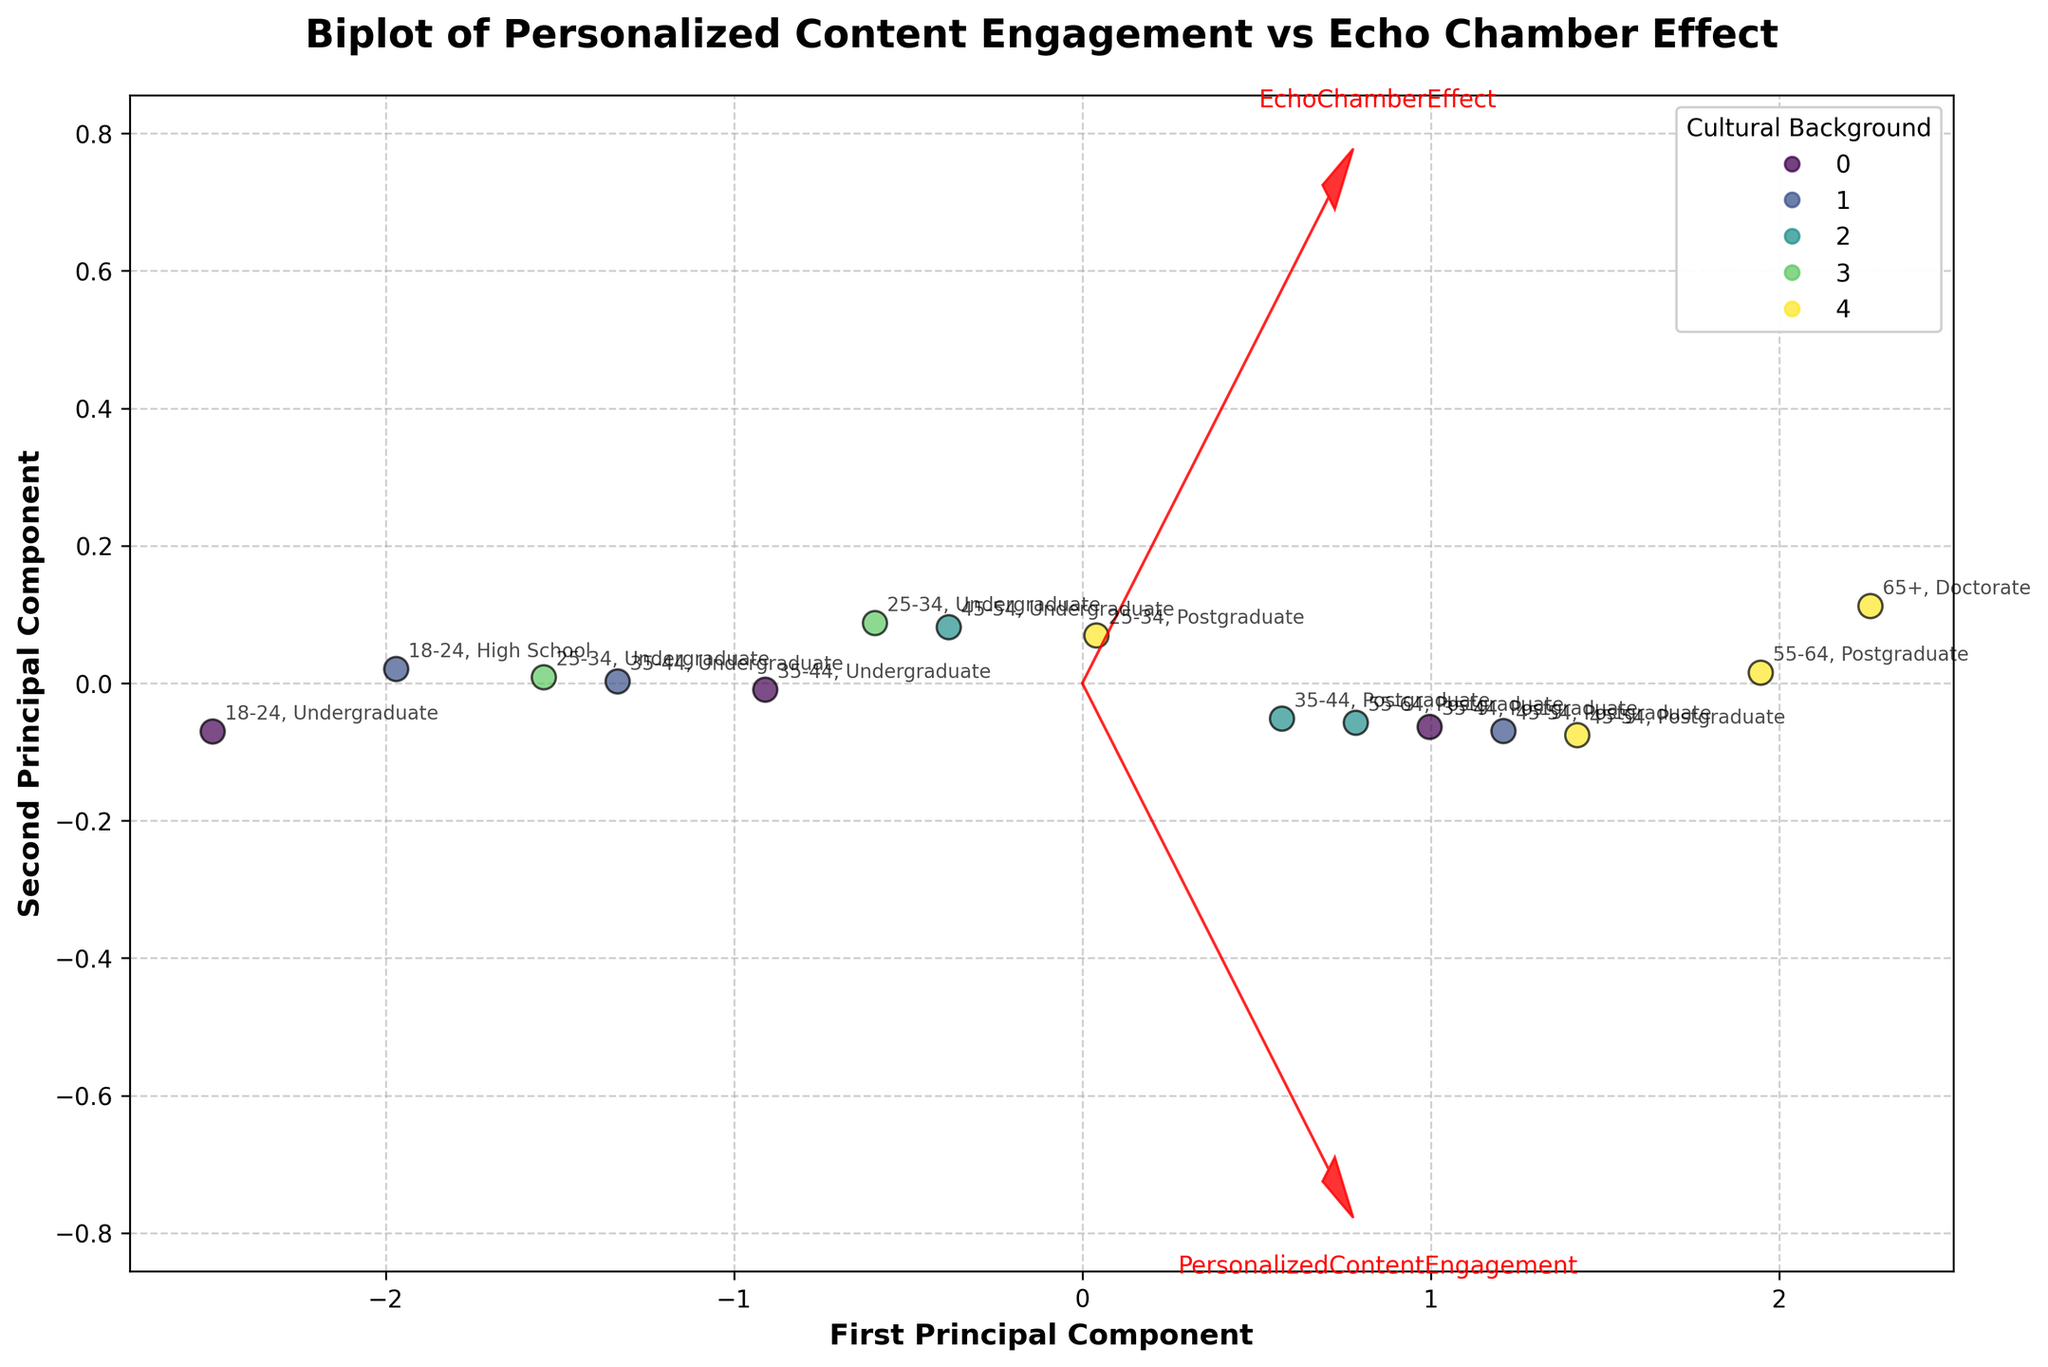What is the title of the figure? The title is displayed at the top of the figure and it reads "Biplot of Personalized Content Engagement vs Echo Chamber Effect".
Answer: Biplot of Personalized Content Engagement vs Echo Chamber Effect Which axis represents the first principal component? The label on the horizontal axis shows "First Principal Component", indicating that it represents the first principal component.
Answer: The horizontal axis How many cultural backgrounds are represented in the plot? The legend on the figure indicates different colors for "Cultural Background" and there are five categories: Western, Asian, African, Latin American, and Middle Eastern.
Answer: Five Which cultural background has the highest data point along the first principal component? Observing the scatter plot, identify the data point farthest to the right along the horizontal axis and refer to its corresponding color and legend.
Answer: Western What information is annotated next to each data point? By looking at the annotations near each data point, it can be observed that they indicate the "Age Group" and "Education Level" of the individual.
Answer: Age Group and Education Level Is there a positive correlation between Personalized Content Engagement and Echo Chamber Effect based on the feature vectors? The red arrows (feature vectors) for Personalized Content Engagement and Echo Chamber Effect both point in a similar direction, indicating a positive correlation.
Answer: Yes What feature is represented by the arrow pointing the furthest to the right? The arrow pointing the furthest right aligns with the label "PersonalizedContentEngagement" next to it.
Answer: PersonalizedContentEngagement Which cultural background appears most frequently in the data points? By counting the number of data points colored according to the legend, the Western background appears most frequently.
Answer: Western Which age group is associated with the highest Personalized Content Engagement? Check the annotations near the data point with the highest value along the direction of the PersonalizedContentEngagement arrow. The annotation indicates "65+" and "Doctorate".
Answer: 65+ Are data points from the Western cultural background more spread out along the first principal component compared to the second principal component? Examining the dispersion of points specifically for the Western cultural background along both principal components, they are more spread from left to right (first principal component) than vertically (second principal component).
Answer: Yes 